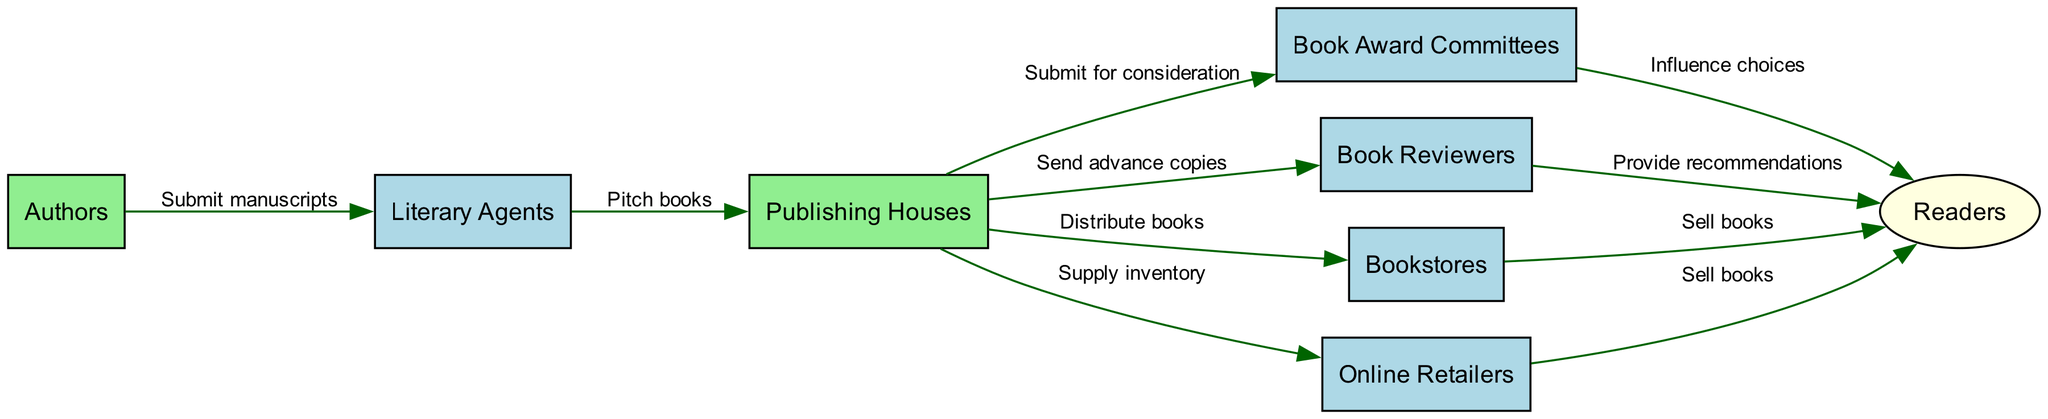What are the primary nodes in the ecosystem? The primary nodes listed in the diagram are Authors, Literary Agents, Publishing Houses, Book Award Committees, Book Reviewers, Bookstores, Online Retailers, and Readers.
Answer: Authors, Literary Agents, Publishing Houses, Book Award Committees, Book Reviewers, Bookstores, Online Retailers, Readers How many edges are in the diagram? The diagram has a total of 10 edges representing the relationships between the nodes. Each edge indicates a connection from one node to another.
Answer: 10 What is the role of Literary Agents in the publishing ecosystem? Literary Agents serve as a intermediary who pitches books to Publishing Houses after receiving manuscripts from Authors. This is shown by the directed edge from Authors to Literary Agents and then to Publishing Houses.
Answer: Pitch books Which node influences reader choices according to the diagram? The Book Award Committees influence reader choices as denoted by the directed edge connecting them to Readers with the label "Influence choices."
Answer: Book Award Committees What do Publishing Houses provide to Book Reviewers? Publishing Houses send advance copies to Book Reviewers to facilitate early assessments and reviews of their books. This is captured in the edge from Publishing Houses to Book Reviewers.
Answer: Send advance copies Which nodes sell books directly to Readers? The nodes that sell books directly to Readers are Bookstores and Online Retailers, as indicated by the edges connecting each of those nodes to Readers with the label "Sell books."
Answer: Bookstores, Online Retailers What action do Authors take towards Literary Agents? Authors submit manuscripts to Literary Agents, which is indicated by the directed edge from Authors to Literary Agents labeled "Submit manuscripts."
Answer: Submit manuscripts What happens after Publishing Houses submit to Book Award Committees? After Publishing Houses submit for consideration to Book Award Committees, these committees, in turn, influence the choices available to Readers, demonstrating a flow of information affecting reader preferences.
Answer: Influence choices Why are there two ways that books reach Readers in the diagram? Books can reach Readers through two different channels: Bookstores and Online Retailers, reflecting the multi-faceted nature of book distribution. Each channel is depicted as a direct connection to Readers with the label "Sell books."
Answer: Bookstores, Online Retailers What is needed for a manuscript to reach the Publishing Houses? A manuscript must first be pitched by Literary Agents to the Publishing Houses, signified by the edge that connects Literary Agents to Publishing Houses with the label "Pitch books."
Answer: Pitch books 